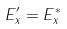Convert formula to latex. <formula><loc_0><loc_0><loc_500><loc_500>E ^ { \prime } _ { x } = E _ { x } ^ { * }</formula> 